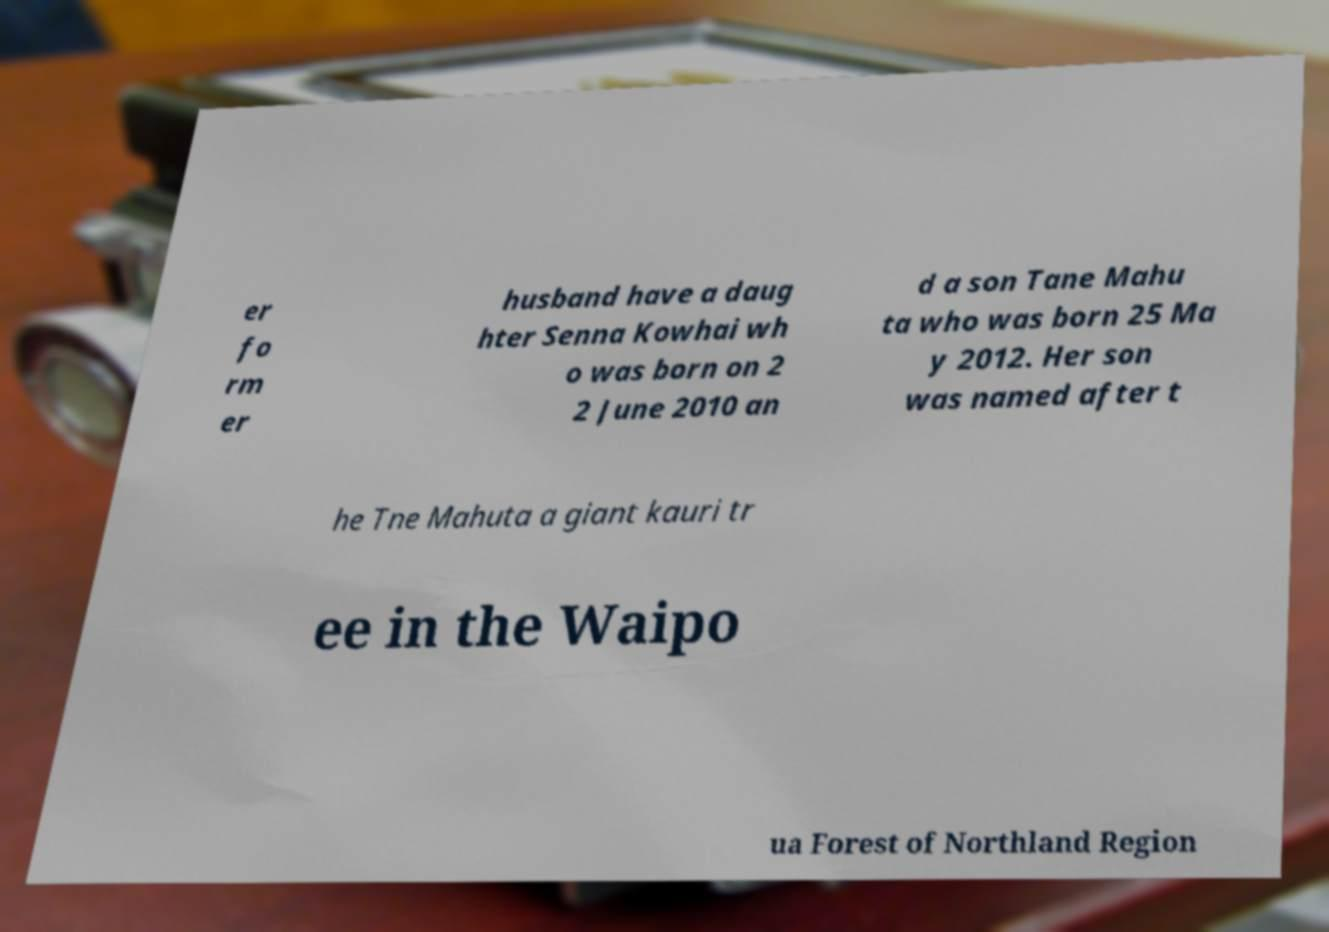What messages or text are displayed in this image? I need them in a readable, typed format. er fo rm er husband have a daug hter Senna Kowhai wh o was born on 2 2 June 2010 an d a son Tane Mahu ta who was born 25 Ma y 2012. Her son was named after t he Tne Mahuta a giant kauri tr ee in the Waipo ua Forest of Northland Region 